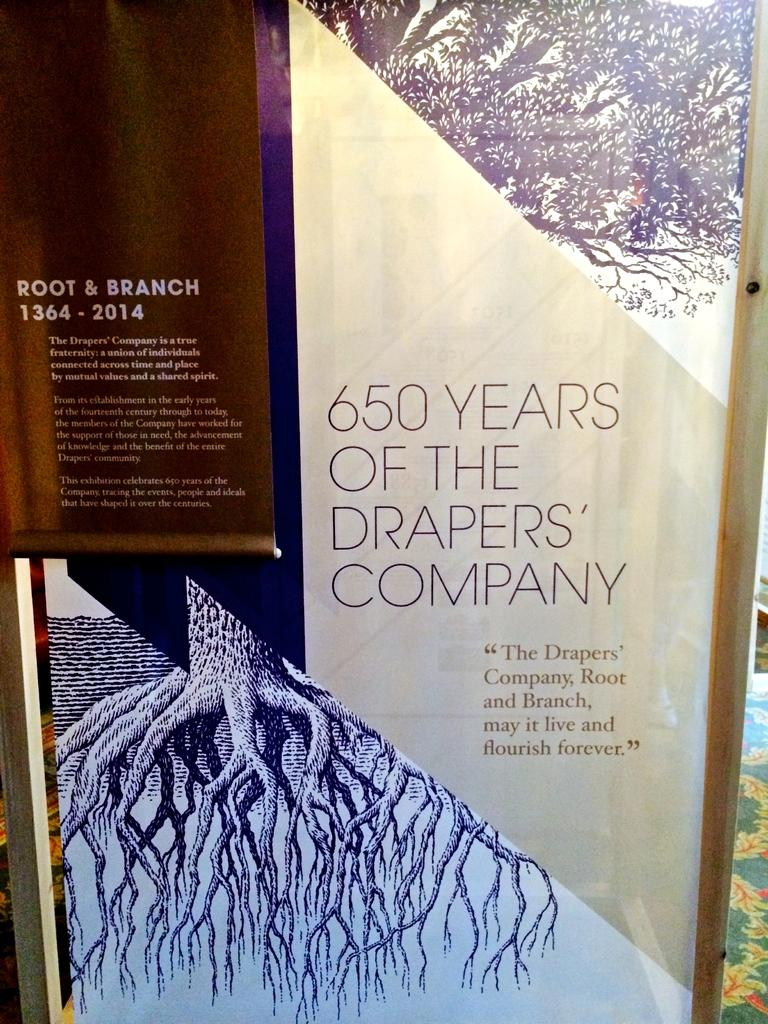<image>
Present a compact description of the photo's key features. A text which talks about the 650 year history of a specific country. 